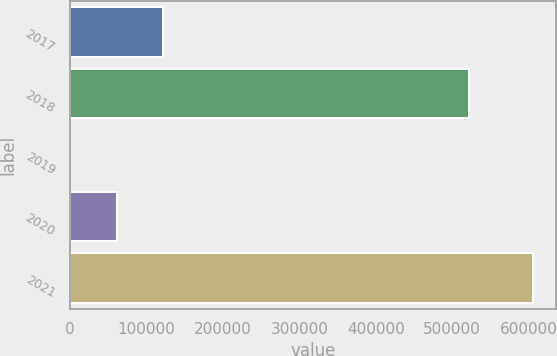Convert chart. <chart><loc_0><loc_0><loc_500><loc_500><bar_chart><fcel>2017<fcel>2018<fcel>2019<fcel>2020<fcel>2021<nl><fcel>121224<fcel>522531<fcel>23<fcel>60623.3<fcel>606026<nl></chart> 